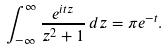Convert formula to latex. <formula><loc_0><loc_0><loc_500><loc_500>\int _ { - \infty } ^ { \infty } { \frac { e ^ { i t z } } { z ^ { 2 } + 1 } } \, d z = \pi e ^ { - t } .</formula> 